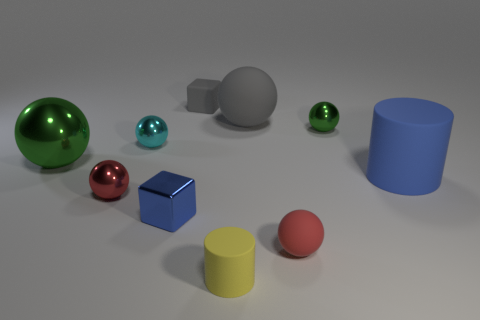Subtract all large green metal balls. How many balls are left? 5 Subtract all green spheres. How many spheres are left? 4 Subtract all red cylinders. How many green spheres are left? 2 Subtract 1 cylinders. How many cylinders are left? 1 Subtract all cylinders. How many objects are left? 8 Add 6 small cyan shiny cylinders. How many small cyan shiny cylinders exist? 6 Subtract 0 cyan blocks. How many objects are left? 10 Subtract all red blocks. Subtract all red balls. How many blocks are left? 2 Subtract all small cylinders. Subtract all large yellow metal balls. How many objects are left? 9 Add 6 tiny gray rubber things. How many tiny gray rubber things are left? 7 